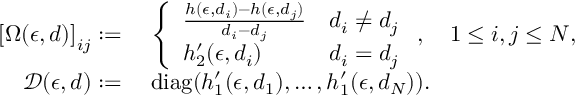<formula> <loc_0><loc_0><loc_500><loc_500>\begin{array} { r l } { \left [ \Omega ( \epsilon , d ) \right ] _ { i j } \colon = } & { \, \left \{ \begin{array} { l l } { \frac { h ( \epsilon , d _ { i } ) - h ( \epsilon , d _ { j } ) } { d _ { i } - d _ { j } } } & { d _ { i } \neq d _ { j } } \\ { h _ { 2 } ^ { \prime } ( \epsilon , d _ { i } ) } & { d _ { i } = d _ { j } } \end{array} , \quad 1 \leq i , j \leq N , } \\ { \mathcal { D } ( \epsilon , d ) \colon = } & { \, d i a g ( h _ { 1 } ^ { \prime } ( \epsilon , d _ { 1 } ) , \dots , h _ { 1 } ^ { \prime } ( \epsilon , d _ { N } ) ) . } \end{array}</formula> 